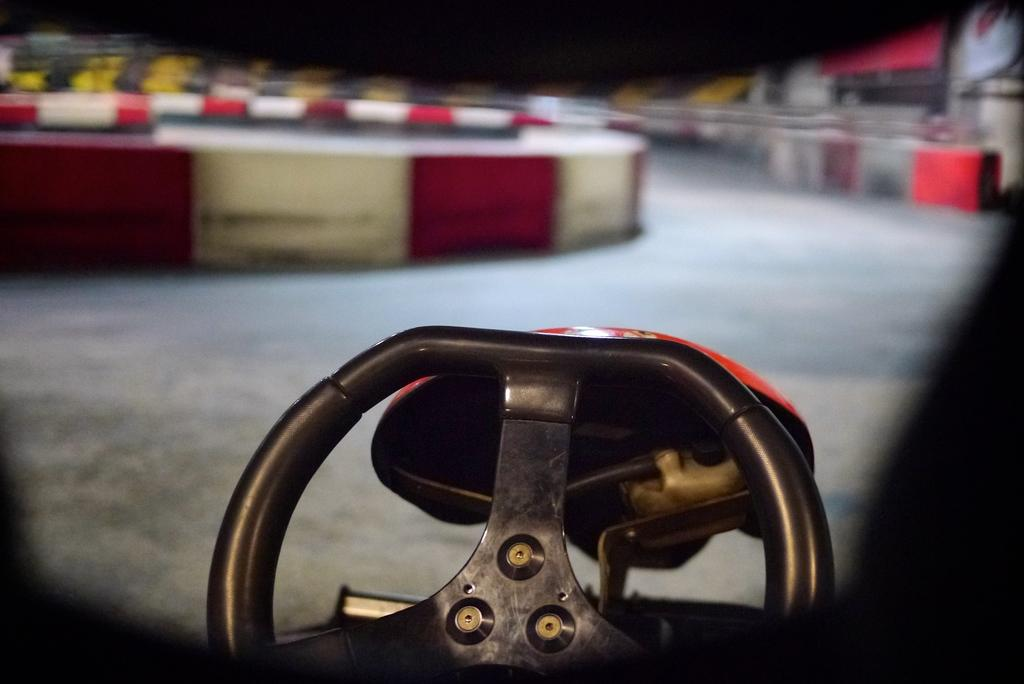Where might the image have been taken? The image might be taken inside a car. What can be seen in the middle of the image? There is a steering wheel in the middle of the image. What is visible outside the car? There is a road visible outside the car. What type of drug can be seen in the image? There is no drug present in the image; it features a steering wheel inside a car with a road visible outside. 